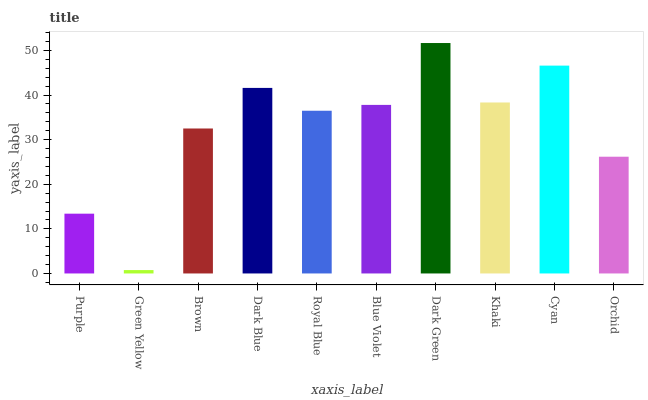Is Green Yellow the minimum?
Answer yes or no. Yes. Is Dark Green the maximum?
Answer yes or no. Yes. Is Brown the minimum?
Answer yes or no. No. Is Brown the maximum?
Answer yes or no. No. Is Brown greater than Green Yellow?
Answer yes or no. Yes. Is Green Yellow less than Brown?
Answer yes or no. Yes. Is Green Yellow greater than Brown?
Answer yes or no. No. Is Brown less than Green Yellow?
Answer yes or no. No. Is Blue Violet the high median?
Answer yes or no. Yes. Is Royal Blue the low median?
Answer yes or no. Yes. Is Green Yellow the high median?
Answer yes or no. No. Is Brown the low median?
Answer yes or no. No. 